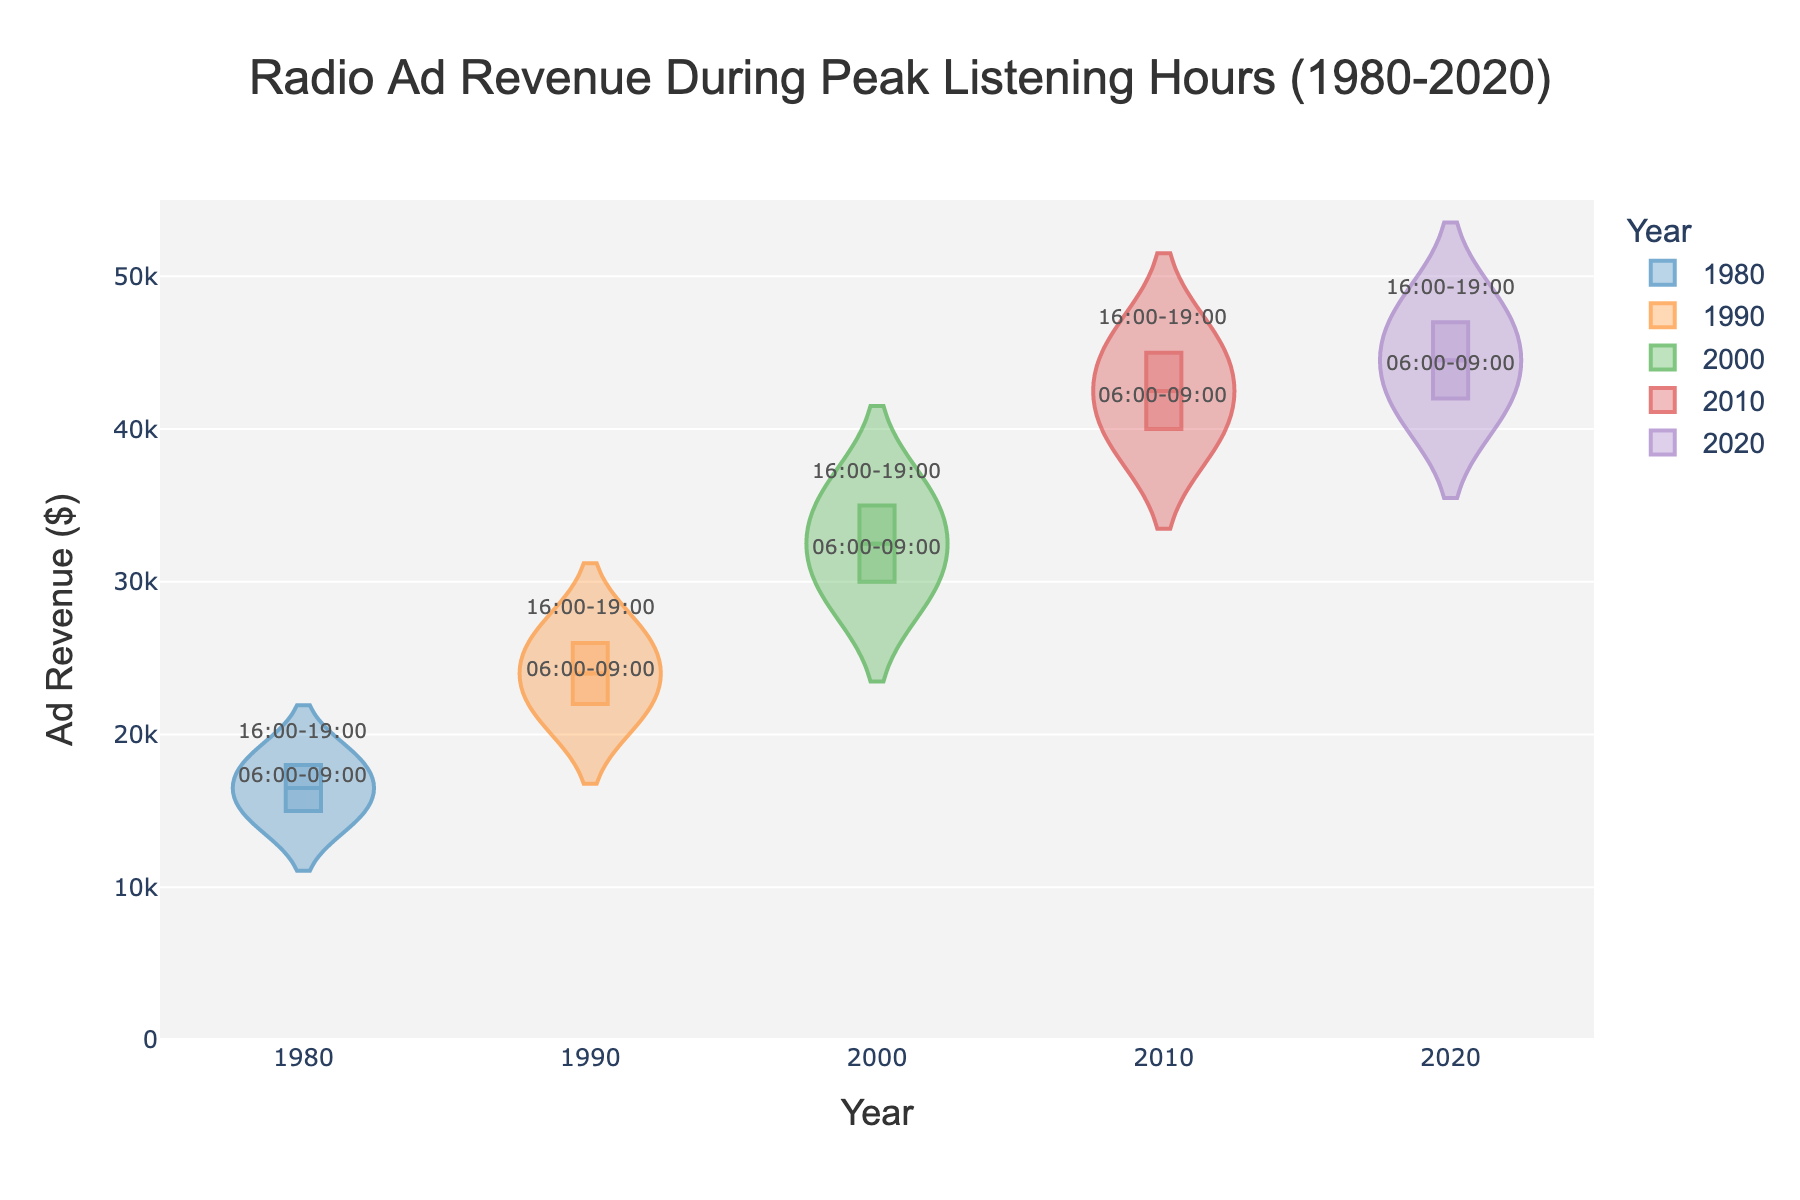What is the title of the figure? The title is usually displayed at the top of the figure. In this case, it indicates the subject and timeframe of the data being visualized.
Answer: Radio Ad Revenue During Peak Listening Hours (1980-2020) What does the x-axis represent? The x-axis labels typically indicate the category or variable along the horizontal direction. Here, it represents the different years the data was collected.
Answer: Years What does the y-axis represent? The y-axis labels usually indicate the measure or variable along the vertical direction. Here, it represents the ad revenue in dollars.
Answer: Ad Revenue ($) Which year shows the highest overall ad revenue? By observing where the highest data points fall on the y-axis, you identify the year with the highest ad revenue. For 2020, the ad revenue is the highest, around $47,000.
Answer: 2020 How does ad revenue in peak morning hours (06:00-09:00) compare between 1980 and 2020? Compare the morning ad revenue for both years by observing their respective points on the y-axis. Morning ad revenue in 1980 is around $15,000, whereas in 2020 it is around $42,000.
Answer: 2020 is higher What is the difference in ad revenue between the peak morning hours (06:00-09:00) and peak evening hours (16:00-19:00) in 2010? Identify the ad revenue for both time slots in 2010 and subtract the morning value from the evening value. In 2010, morning revenue is $40,000 and evening revenue is $45,000, so the difference is $5,000.
Answer: $5,000 Which year had the smallest increase in ad revenue between morning and evening hours? Calculate the difference in ad revenue between morning and evening hours for each year and determine which is the smallest. 1980 had $15,000 (morning) and $18,000 (evening), creating the smallest difference of $3,000.
Answer: 1980 How many distinct years are represented in the plot? Count the unique years displayed along the x-axis. There are five unique years shown: 1980, 1990, 2000, 2010, and 2020.
Answer: Five In which year did ad revenue first exceed $30,000 during peak listening hours? Identify the first occurrence on the plot where ad revenue surpasses $30,000. In the year 2000, the ad revenue exceeds $30,000 during peak evening hours (16:00-19:00).
Answer: 2000 